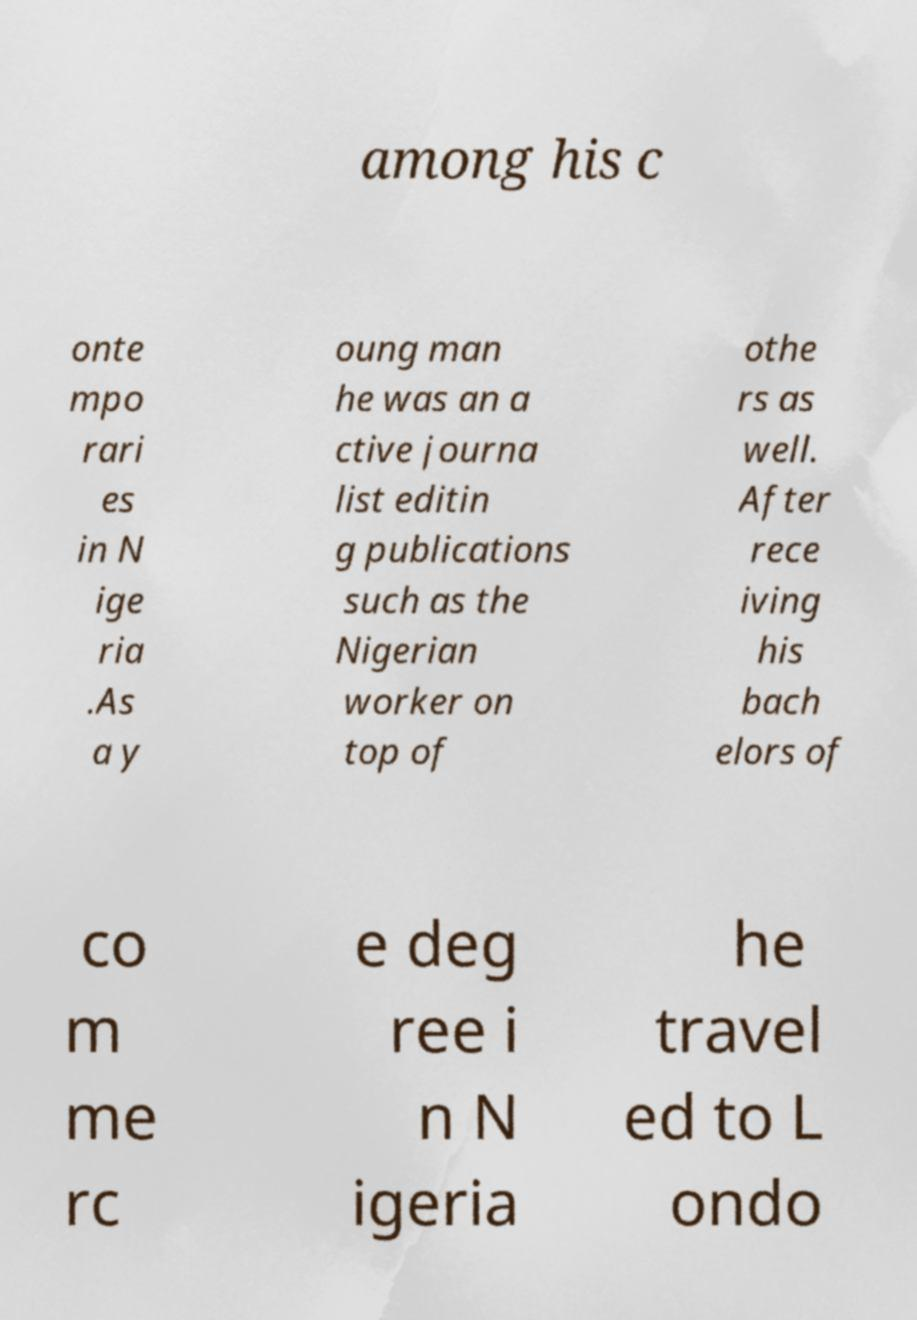For documentation purposes, I need the text within this image transcribed. Could you provide that? among his c onte mpo rari es in N ige ria .As a y oung man he was an a ctive journa list editin g publications such as the Nigerian worker on top of othe rs as well. After rece iving his bach elors of co m me rc e deg ree i n N igeria he travel ed to L ondo 